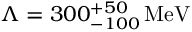Convert formula to latex. <formula><loc_0><loc_0><loc_500><loc_500>\Lambda = 3 0 0 _ { - 1 0 0 } ^ { + 5 0 } \, M e V</formula> 